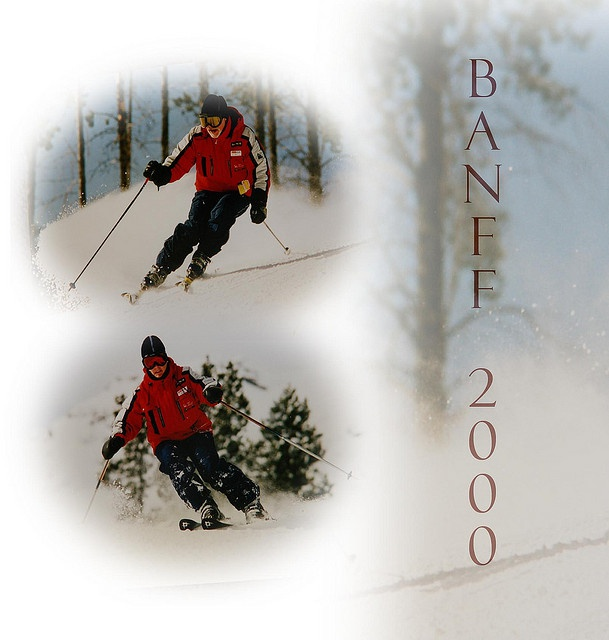Describe the objects in this image and their specific colors. I can see people in white, black, maroon, darkgray, and gray tones, people in white, black, maroon, and darkgray tones, skis in white, darkgray, tan, and olive tones, and skis in white, black, gray, and darkgray tones in this image. 